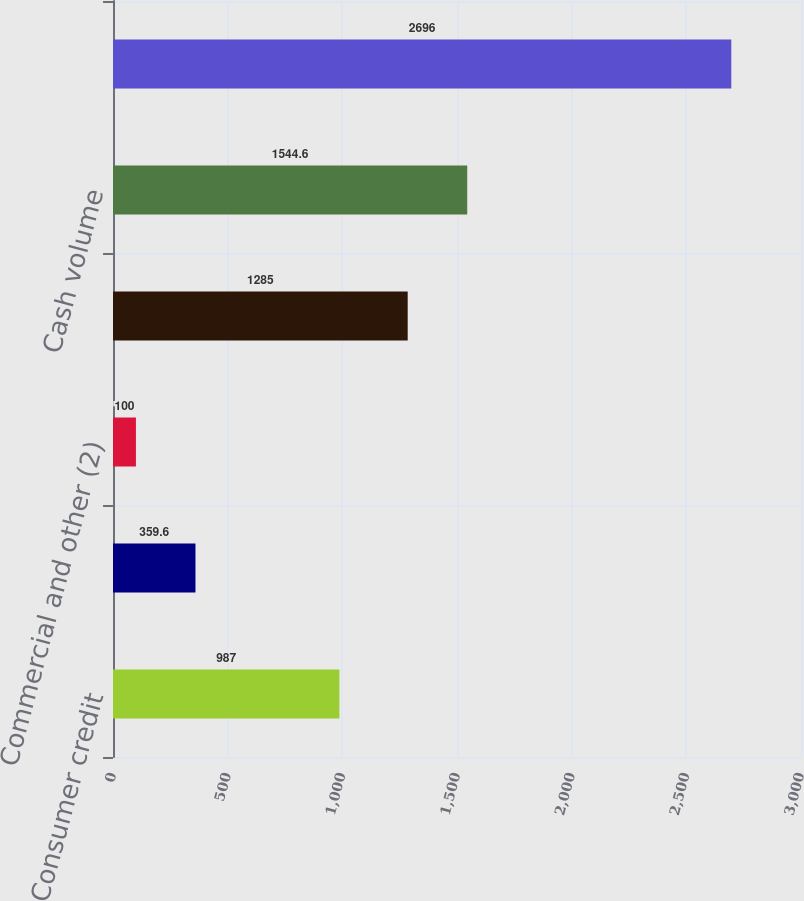Convert chart. <chart><loc_0><loc_0><loc_500><loc_500><bar_chart><fcel>Consumer credit<fcel>Consumer debit (2)<fcel>Commercial and other (2)<fcel>Total Nominal Payments Volume<fcel>Cash volume<fcel>Total Nominal Volume (3)<nl><fcel>987<fcel>359.6<fcel>100<fcel>1285<fcel>1544.6<fcel>2696<nl></chart> 